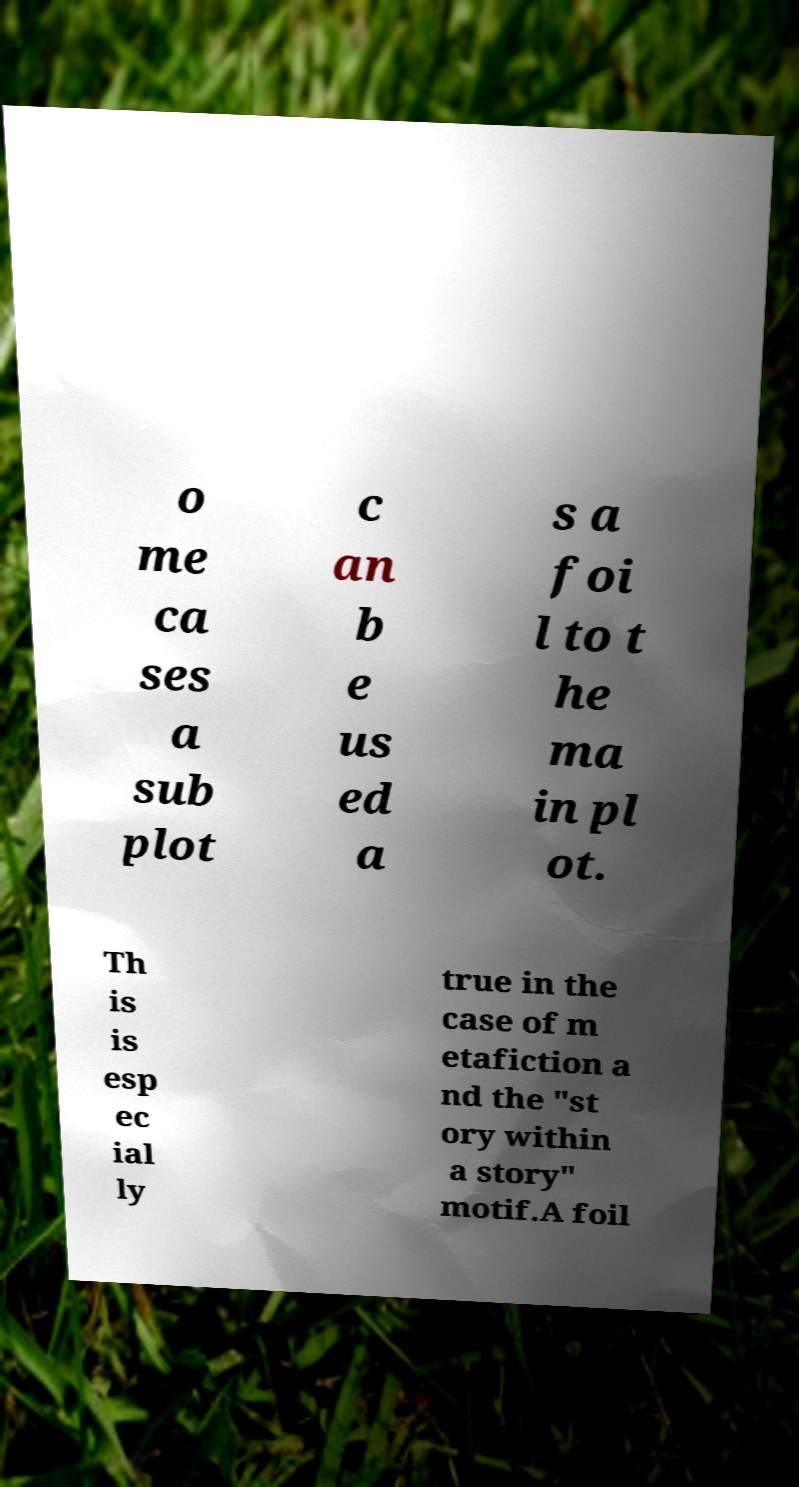Could you assist in decoding the text presented in this image and type it out clearly? o me ca ses a sub plot c an b e us ed a s a foi l to t he ma in pl ot. Th is is esp ec ial ly true in the case of m etafiction a nd the "st ory within a story" motif.A foil 